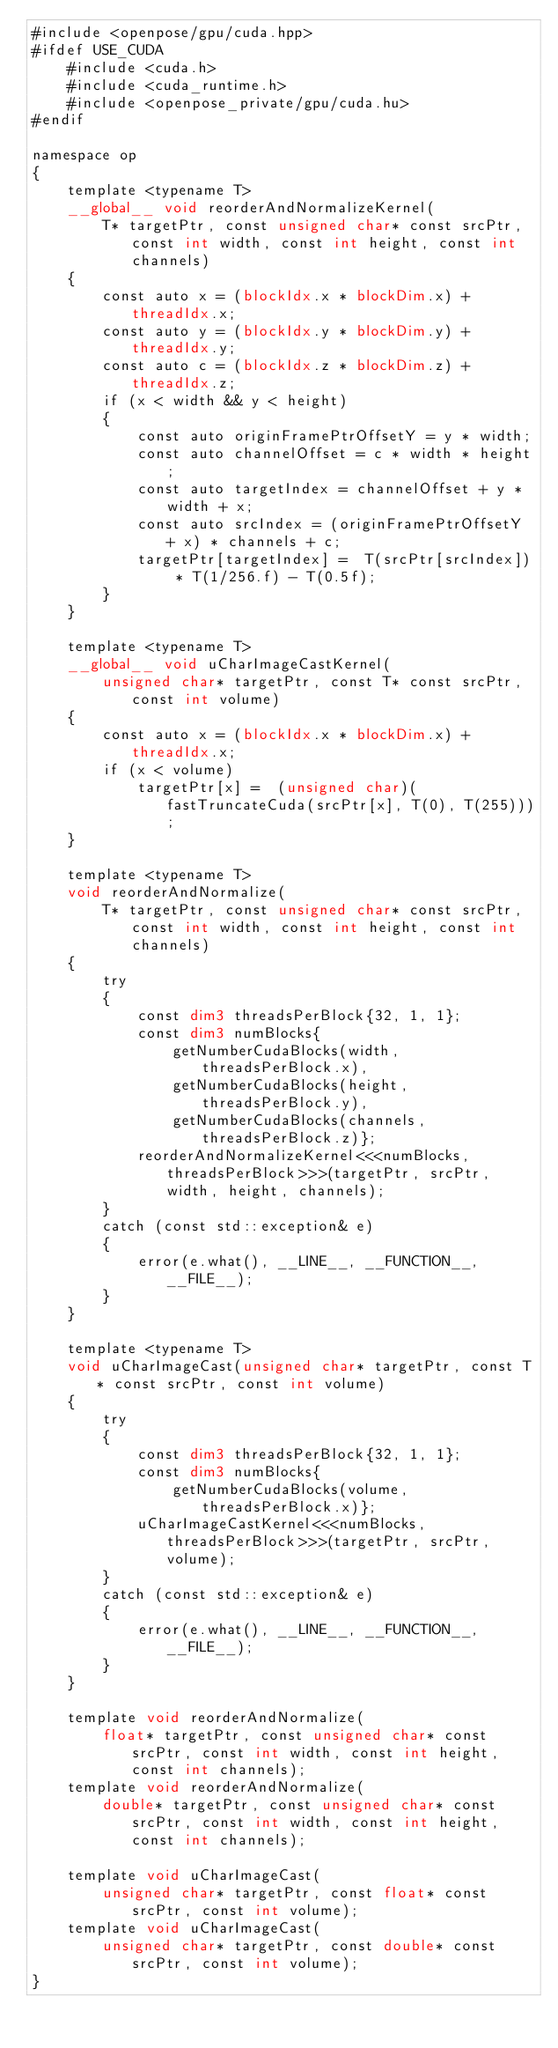Convert code to text. <code><loc_0><loc_0><loc_500><loc_500><_Cuda_>#include <openpose/gpu/cuda.hpp>
#ifdef USE_CUDA
    #include <cuda.h>
    #include <cuda_runtime.h>
    #include <openpose_private/gpu/cuda.hu>
#endif

namespace op
{
    template <typename T>
    __global__ void reorderAndNormalizeKernel(
        T* targetPtr, const unsigned char* const srcPtr, const int width, const int height, const int channels)
    {
        const auto x = (blockIdx.x * blockDim.x) + threadIdx.x;
        const auto y = (blockIdx.y * blockDim.y) + threadIdx.y;
        const auto c = (blockIdx.z * blockDim.z) + threadIdx.z;
        if (x < width && y < height)
        {
            const auto originFramePtrOffsetY = y * width;
            const auto channelOffset = c * width * height;
            const auto targetIndex = channelOffset + y * width + x;
            const auto srcIndex = (originFramePtrOffsetY + x) * channels + c;
            targetPtr[targetIndex] =  T(srcPtr[srcIndex]) * T(1/256.f) - T(0.5f);
        }
    }

    template <typename T>
    __global__ void uCharImageCastKernel(
        unsigned char* targetPtr, const T* const srcPtr, const int volume)
    {
        const auto x = (blockIdx.x * blockDim.x) + threadIdx.x;
        if (x < volume)
            targetPtr[x] =  (unsigned char)(fastTruncateCuda(srcPtr[x], T(0), T(255)));
    }

    template <typename T>
    void reorderAndNormalize(
        T* targetPtr, const unsigned char* const srcPtr, const int width, const int height, const int channels)
    {
        try
        {
            const dim3 threadsPerBlock{32, 1, 1};
            const dim3 numBlocks{
                getNumberCudaBlocks(width, threadsPerBlock.x),
                getNumberCudaBlocks(height, threadsPerBlock.y),
                getNumberCudaBlocks(channels, threadsPerBlock.z)};
            reorderAndNormalizeKernel<<<numBlocks, threadsPerBlock>>>(targetPtr, srcPtr, width, height, channels);
        }
        catch (const std::exception& e)
        {
            error(e.what(), __LINE__, __FUNCTION__, __FILE__);
        }
    }

    template <typename T>
    void uCharImageCast(unsigned char* targetPtr, const T* const srcPtr, const int volume)
    {
        try
        {
            const dim3 threadsPerBlock{32, 1, 1};
            const dim3 numBlocks{
                getNumberCudaBlocks(volume, threadsPerBlock.x)};
            uCharImageCastKernel<<<numBlocks, threadsPerBlock>>>(targetPtr, srcPtr, volume);
        }
        catch (const std::exception& e)
        {
            error(e.what(), __LINE__, __FUNCTION__, __FILE__);
        }
    }

    template void reorderAndNormalize(
        float* targetPtr, const unsigned char* const srcPtr, const int width, const int height, const int channels);
    template void reorderAndNormalize(
        double* targetPtr, const unsigned char* const srcPtr, const int width, const int height, const int channels);

    template void uCharImageCast(
        unsigned char* targetPtr, const float* const srcPtr, const int volume);
    template void uCharImageCast(
        unsigned char* targetPtr, const double* const srcPtr, const int volume);
}
</code> 